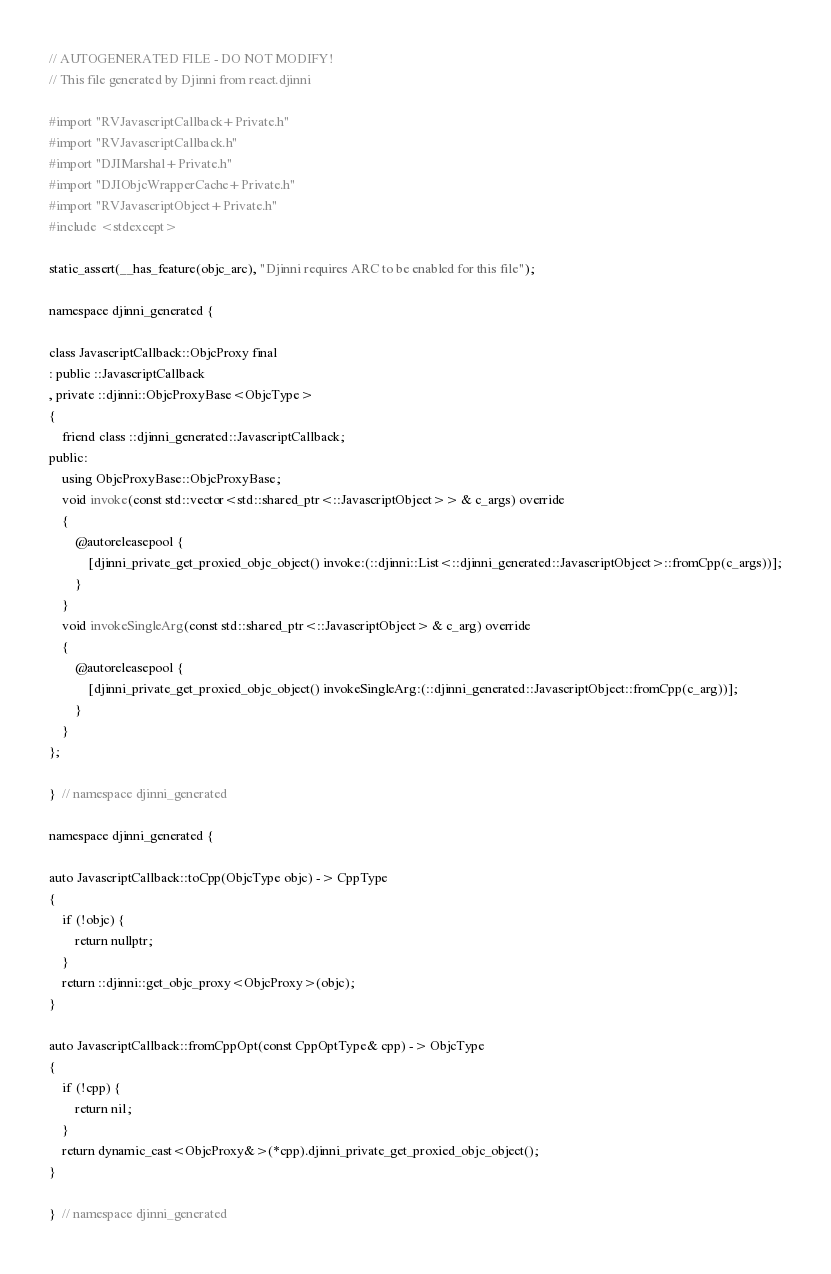<code> <loc_0><loc_0><loc_500><loc_500><_ObjectiveC_>// AUTOGENERATED FILE - DO NOT MODIFY!
// This file generated by Djinni from react.djinni

#import "RVJavascriptCallback+Private.h"
#import "RVJavascriptCallback.h"
#import "DJIMarshal+Private.h"
#import "DJIObjcWrapperCache+Private.h"
#import "RVJavascriptObject+Private.h"
#include <stdexcept>

static_assert(__has_feature(objc_arc), "Djinni requires ARC to be enabled for this file");

namespace djinni_generated {

class JavascriptCallback::ObjcProxy final
: public ::JavascriptCallback
, private ::djinni::ObjcProxyBase<ObjcType>
{
    friend class ::djinni_generated::JavascriptCallback;
public:
    using ObjcProxyBase::ObjcProxyBase;
    void invoke(const std::vector<std::shared_ptr<::JavascriptObject>> & c_args) override
    {
        @autoreleasepool {
            [djinni_private_get_proxied_objc_object() invoke:(::djinni::List<::djinni_generated::JavascriptObject>::fromCpp(c_args))];
        }
    }
    void invokeSingleArg(const std::shared_ptr<::JavascriptObject> & c_arg) override
    {
        @autoreleasepool {
            [djinni_private_get_proxied_objc_object() invokeSingleArg:(::djinni_generated::JavascriptObject::fromCpp(c_arg))];
        }
    }
};

}  // namespace djinni_generated

namespace djinni_generated {

auto JavascriptCallback::toCpp(ObjcType objc) -> CppType
{
    if (!objc) {
        return nullptr;
    }
    return ::djinni::get_objc_proxy<ObjcProxy>(objc);
}

auto JavascriptCallback::fromCppOpt(const CppOptType& cpp) -> ObjcType
{
    if (!cpp) {
        return nil;
    }
    return dynamic_cast<ObjcProxy&>(*cpp).djinni_private_get_proxied_objc_object();
}

}  // namespace djinni_generated
</code> 